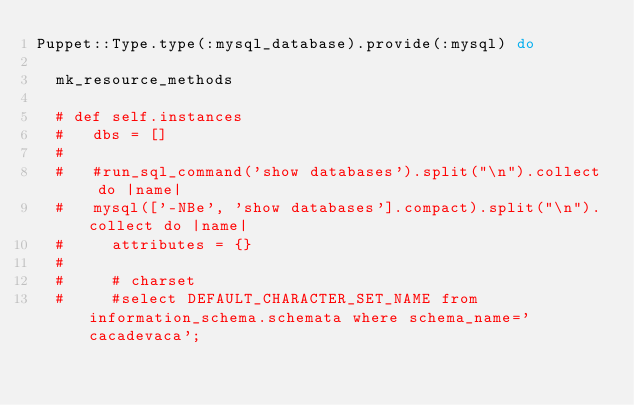<code> <loc_0><loc_0><loc_500><loc_500><_Ruby_>Puppet::Type.type(:mysql_database).provide(:mysql) do

  mk_resource_methods

  # def self.instances
  #   dbs = []
  #
  #   #run_sql_command('show databases').split("\n").collect do |name|
  #   mysql(['-NBe', 'show databases'].compact).split("\n").collect do |name|
  #     attributes = {}
  #
  #     # charset
  #     #select DEFAULT_CHARACTER_SET_NAME from information_schema.schemata where schema_name='cacadevaca';</code> 